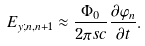<formula> <loc_0><loc_0><loc_500><loc_500>E _ { y ; n , n + 1 } \approx \frac { \Phi _ { 0 } } { 2 \pi s c } \frac { \partial \varphi _ { n } } { \partial t } .</formula> 